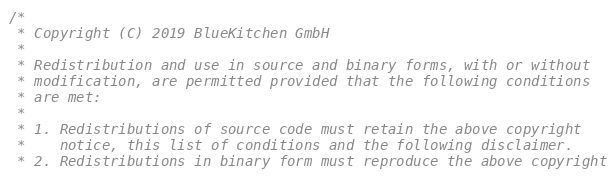Convert code to text. <code><loc_0><loc_0><loc_500><loc_500><_C_>/*
 * Copyright (C) 2019 BlueKitchen GmbH
 *
 * Redistribution and use in source and binary forms, with or without
 * modification, are permitted provided that the following conditions
 * are met:
 *
 * 1. Redistributions of source code must retain the above copyright
 *    notice, this list of conditions and the following disclaimer.
 * 2. Redistributions in binary form must reproduce the above copyright</code> 